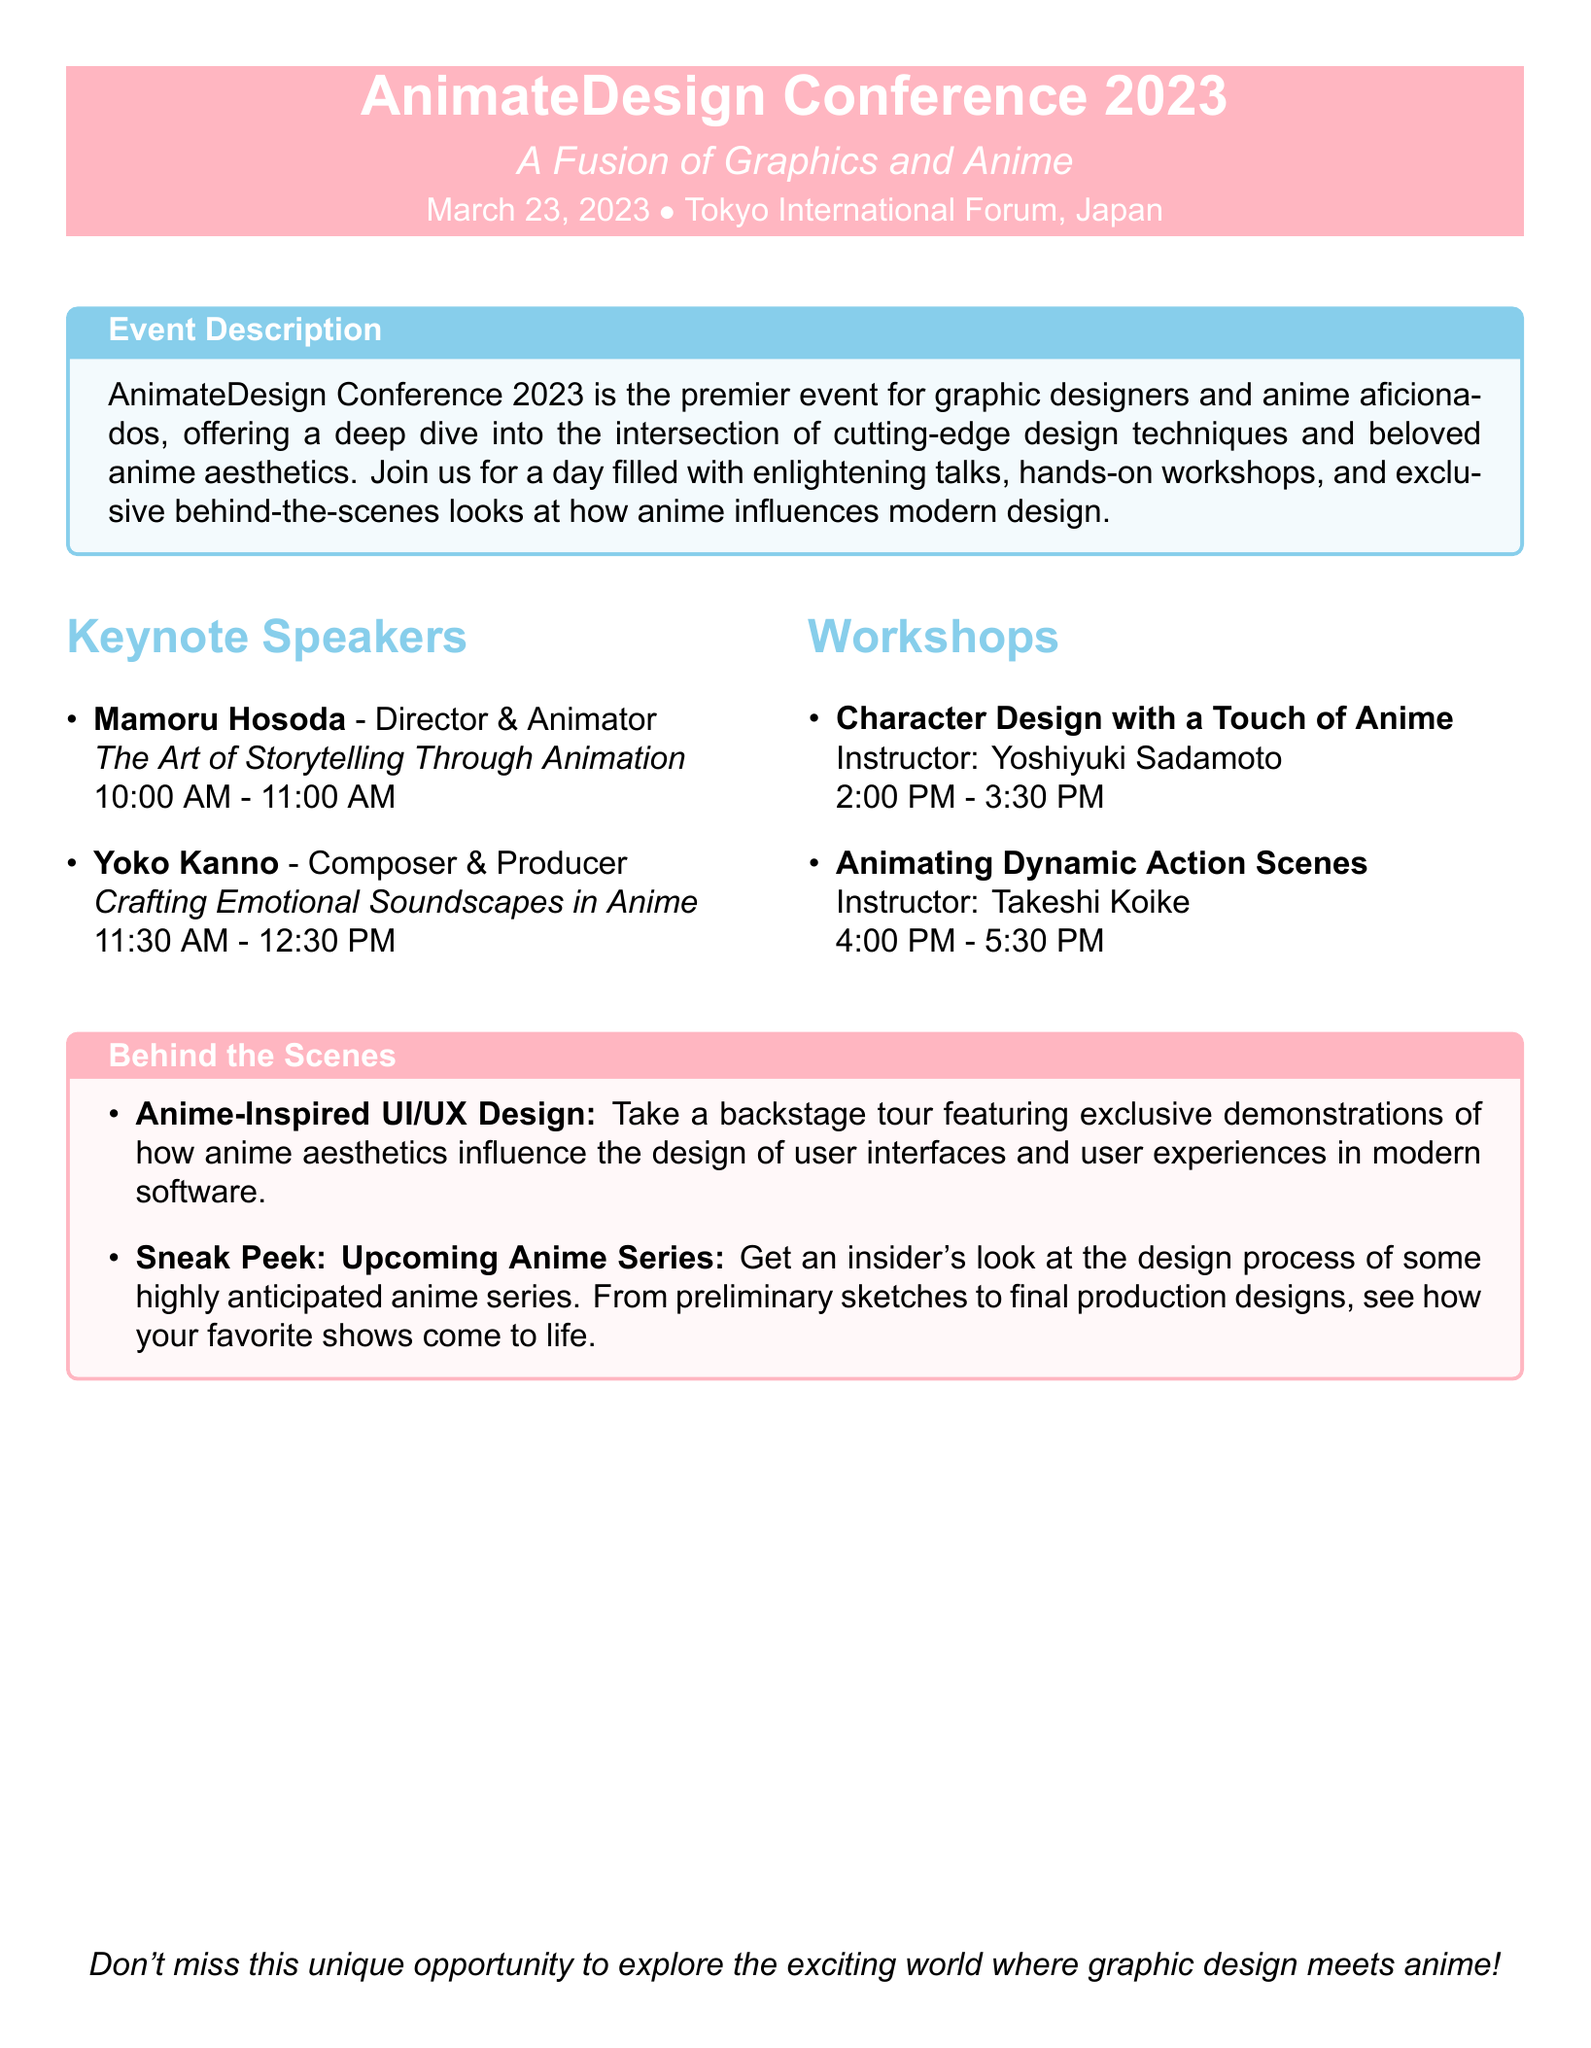What is the date of the conference? The date of the conference is explicitly stated in the document as March 23, 2023.
Answer: March 23, 2023 Who is the keynote speaker discussing storytelling? The document lists Mamoru Hosoda as the keynote speaker for the topic of storytelling through animation.
Answer: Mamoru Hosoda What is the time for Yoko Kanno's keynote? The document mentions that Yoko Kanno's keynote takes place from 11:30 AM to 12:30 PM.
Answer: 11:30 AM - 12:30 PM How long is the workshop on Character Design? The workshop duration is indicated in the document as 1.5 hours (from 2:00 PM to 3:30 PM).
Answer: 1.5 hours What theme is used for the Behind the Scenes section? The document highlights 'Anime-Inspired UI/UX Design' as a theme in the Behind the Scenes section.
Answer: Anime-Inspired UI/UX Design How many keynote speakers are listed in the document? By counting the keynote speakers mentioned, there are two listed in the document.
Answer: Two What type of event is AnimateDesign Conference 2023? Based on the description in the document, the event is a conference focusing on design and anime.
Answer: Conference Who is the instructor for the workshop on Dynamic Action Scenes? The document clearly states that Takeshi Koike is the instructor for this workshop.
Answer: Takeshi Koike 